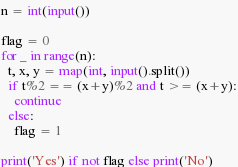Convert code to text. <code><loc_0><loc_0><loc_500><loc_500><_Python_>n = int(input())

flag = 0
for _ in range(n):
  t, x, y = map(int, input().split())
  if t%2 == (x+y)%2 and t >= (x+y):
    continue
  else:
    flag = 1
    
print('Yes') if not flag else print('No')</code> 